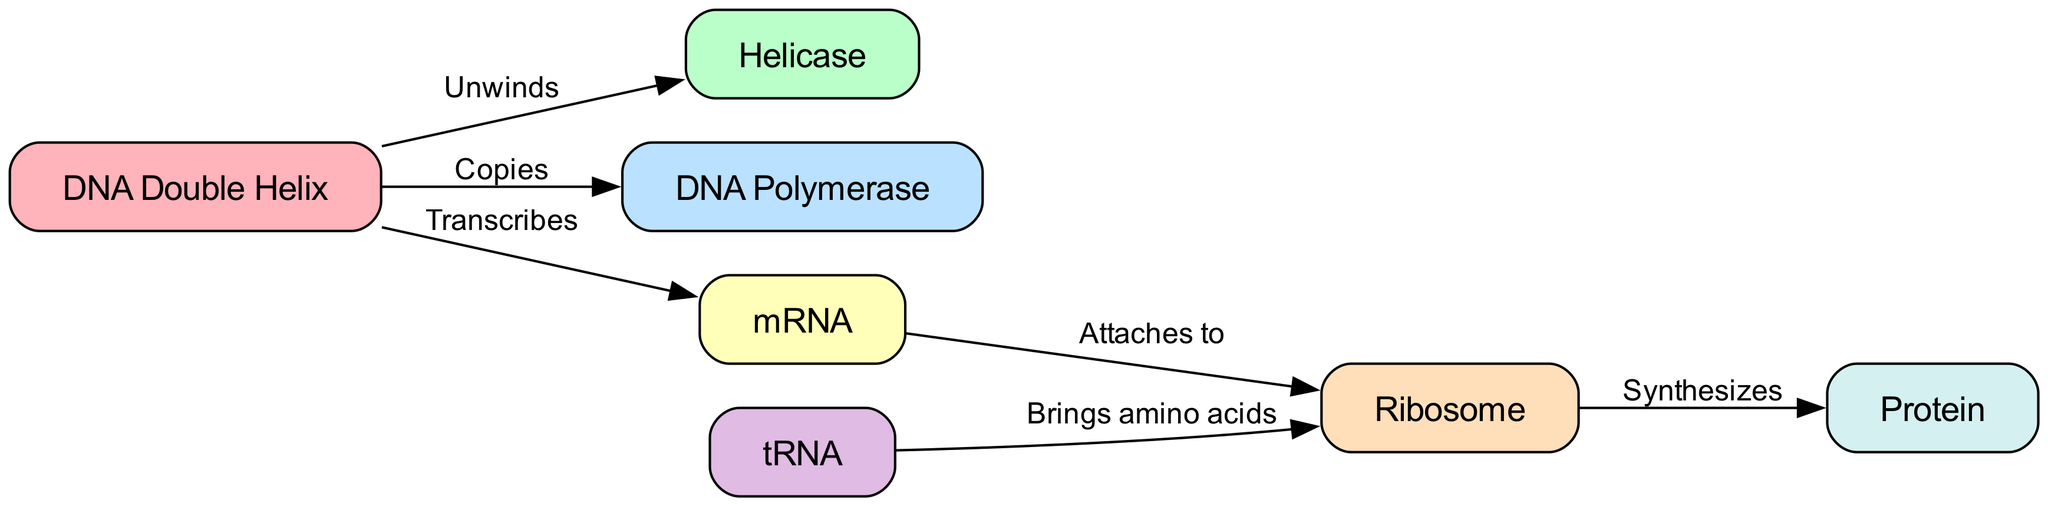What is the starting point of DNA replication? The diagram shows the DNA double helix as the first node, indicating that it is the starting point of DNA replication, which is where the process begins before helicase unwinds it.
Answer: DNA Double Helix Which enzyme is responsible for unwinding the DNA? The diagram indicates that helicase is the enzyme that unwinds the DNA double helix, as shown by the edge labeled "Unwinds" leading from DNA to helicase.
Answer: Helicase How many total nodes are present in this diagram? By counting the nodes listed in the diagram data (DNA Double Helix, Helicase, DNA Polymerase, mRNA, Ribosome, tRNA, Protein), we find there are seven nodes.
Answer: 7 What is the relationship between mRNA and the ribosome? The diagram indicates that mRNA attaches to the ribosome, as shown by the edge labeled "Attaches to" connecting mRNA to ribosome.
Answer: Attaches to Which molecule brings amino acids to the ribosome? The diagram shows that tRNA is responsible for bringing amino acids to the ribosome, as represented by the edge labeled "Brings amino acids" connecting tRNA to ribosome.
Answer: tRNA What is synthesized by the ribosome? According to the diagram, the ribosome synthesizes protein, as indicated by the edge labeled "Synthesizes" leading from ribosome to protein.
Answer: Protein What process does DNA polymerase perform during replication? The diagram shows that DNA polymerase copies the DNA, indicated by the direct edge labeled "Copies" leading from DNA to DNA Polymerase.
Answer: Copies During which step does transcription occur? The diagram illustrates that transcription occurs when DNA is transcribed into mRNA, as shown by the edge labeled "Transcribes" from DNA to mRNA.
Answer: Transcription What is the final product of the process shown in the diagram? The diagram indicates that the final product of the processes of DNA replication and protein synthesis is the protein, as shown by the node labeled "Protein" at the end of the flow.
Answer: Protein 